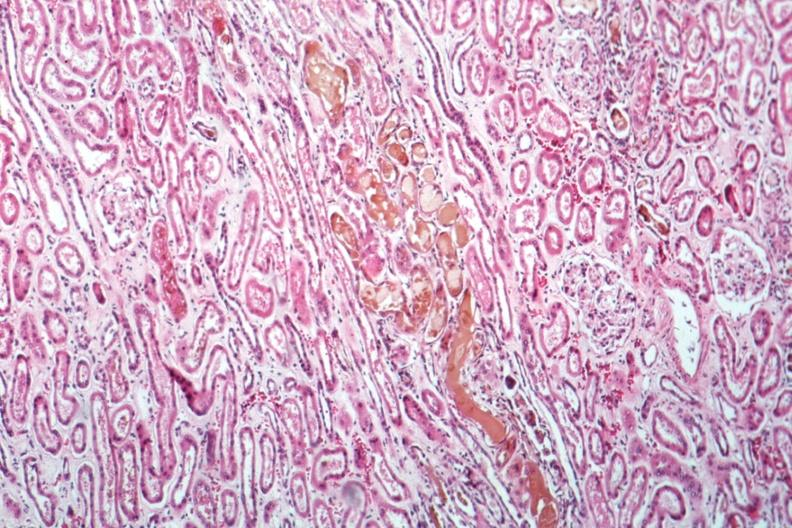what is present?
Answer the question using a single word or phrase. Acute tubular necrosis 